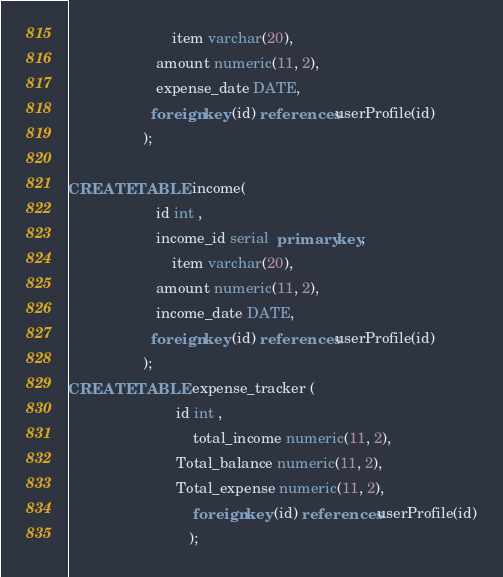<code> <loc_0><loc_0><loc_500><loc_500><_SQL_>				    	 item varchar(20),
					 amount numeric(11, 2),
					 expense_date DATE,
					foreign key (id) references userProfile(id)
				  );

CREATE TABLE income( 			 
					 id int ,
					 income_id serial  primary key,
				    	 item varchar(20),
					 amount numeric(11, 2),
					 income_date DATE,
					foreign key (id) references userProfile(id)
				  );
CREATE TABLE expense_tracker (   
					      id int ,
				              total_income numeric(11, 2),
					      Total_balance numeric(11, 2),
					      Total_expense numeric(11, 2),
	                          foreign key (id) references userProfile(id)
				             );
</code> 